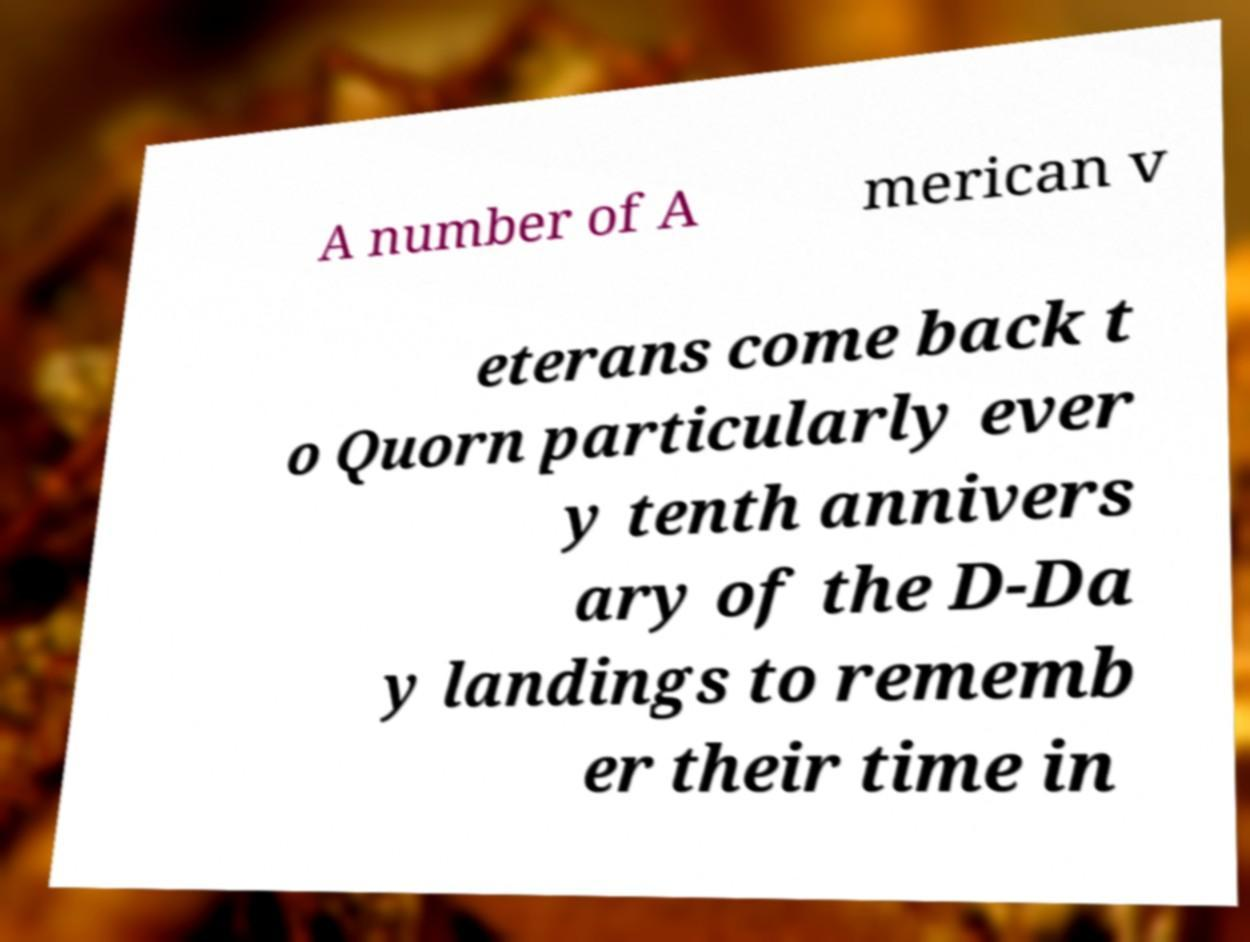There's text embedded in this image that I need extracted. Can you transcribe it verbatim? A number of A merican v eterans come back t o Quorn particularly ever y tenth annivers ary of the D-Da y landings to rememb er their time in 